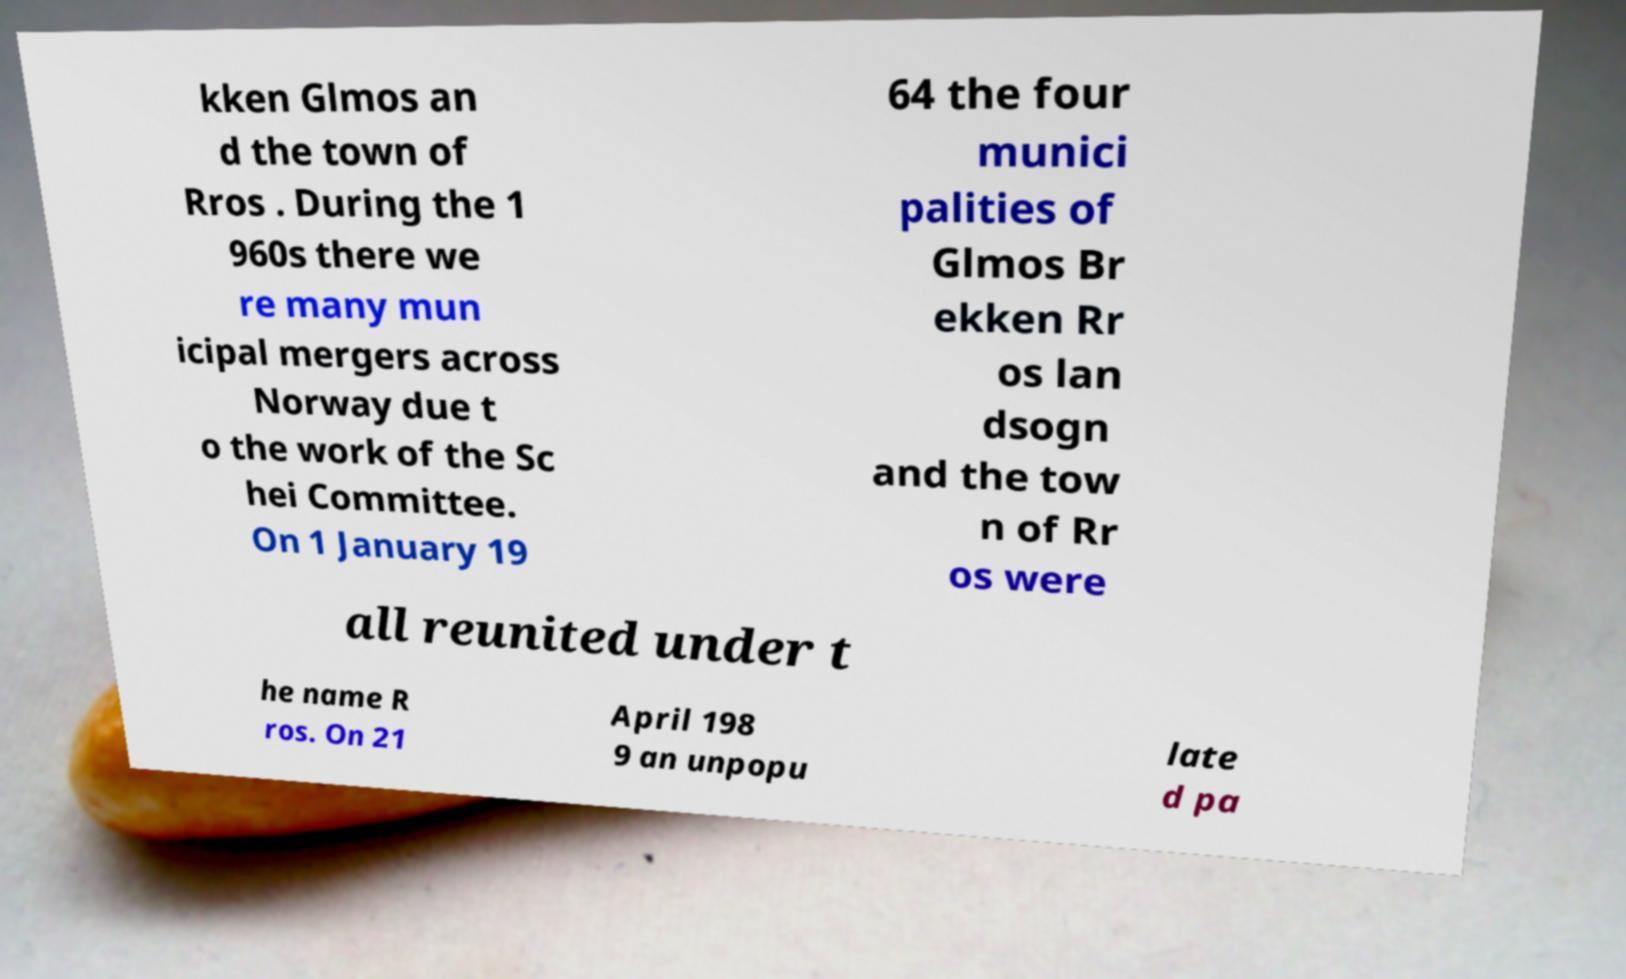Please read and relay the text visible in this image. What does it say? kken Glmos an d the town of Rros . During the 1 960s there we re many mun icipal mergers across Norway due t o the work of the Sc hei Committee. On 1 January 19 64 the four munici palities of Glmos Br ekken Rr os lan dsogn and the tow n of Rr os were all reunited under t he name R ros. On 21 April 198 9 an unpopu late d pa 